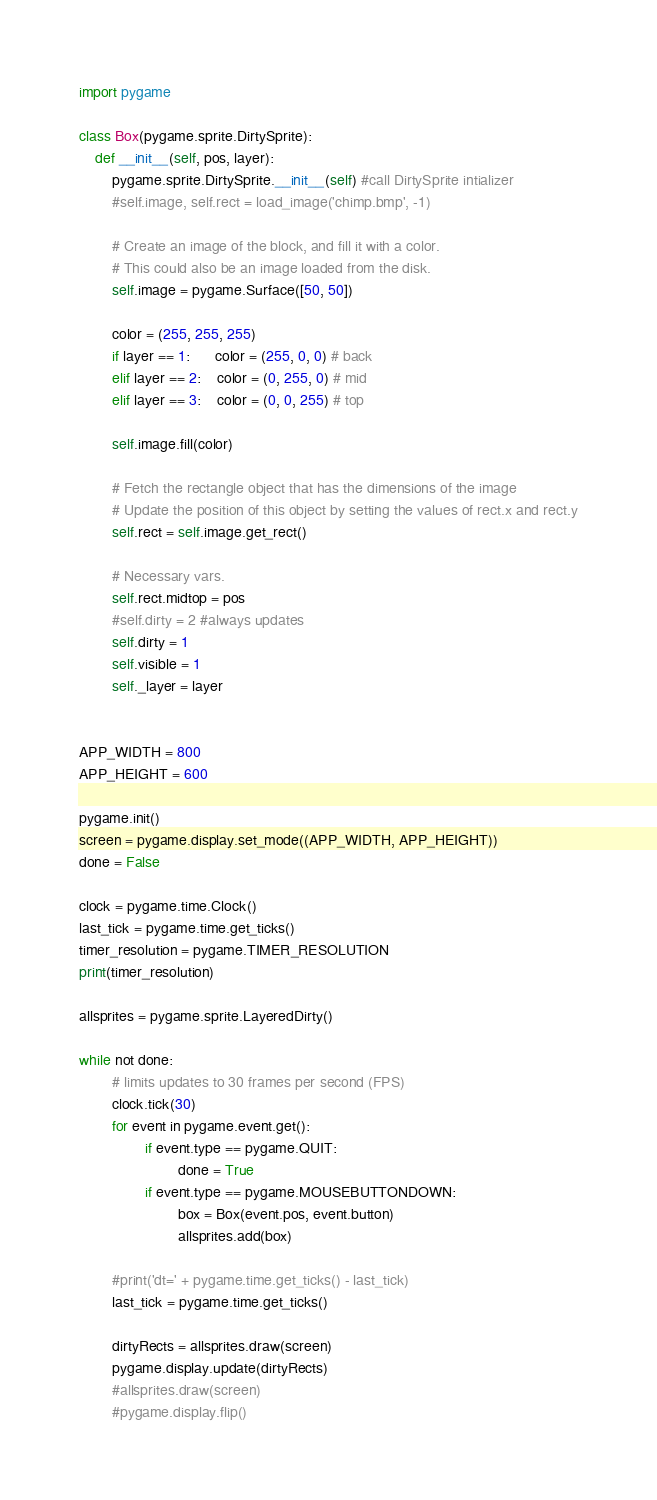Convert code to text. <code><loc_0><loc_0><loc_500><loc_500><_Python_>import pygame

class Box(pygame.sprite.DirtySprite):
    def __init__(self, pos, layer):
        pygame.sprite.DirtySprite.__init__(self) #call DirtySprite intializer
        #self.image, self.rect = load_image('chimp.bmp', -1)

        # Create an image of the block, and fill it with a color.
        # This could also be an image loaded from the disk.
        self.image = pygame.Surface([50, 50])

        color = (255, 255, 255)
        if layer == 1:      color = (255, 0, 0) # back
        elif layer == 2:    color = (0, 255, 0) # mid
        elif layer == 3:    color = (0, 0, 255) # top

        self.image.fill(color)

        # Fetch the rectangle object that has the dimensions of the image
        # Update the position of this object by setting the values of rect.x and rect.y
        self.rect = self.image.get_rect()

        # Necessary vars.
        self.rect.midtop = pos
        #self.dirty = 2 #always updates
        self.dirty = 1
        self.visible = 1
        self._layer = layer


APP_WIDTH = 800
APP_HEIGHT = 600

pygame.init()
screen = pygame.display.set_mode((APP_WIDTH, APP_HEIGHT))
done = False

clock = pygame.time.Clock()
last_tick = pygame.time.get_ticks()
timer_resolution = pygame.TIMER_RESOLUTION
print(timer_resolution)

allsprites = pygame.sprite.LayeredDirty()

while not done:
        # limits updates to 30 frames per second (FPS)
        clock.tick(30)
        for event in pygame.event.get():
                if event.type == pygame.QUIT:
                        done = True
                if event.type == pygame.MOUSEBUTTONDOWN:
                        box = Box(event.pos, event.button)
                        allsprites.add(box)

        #print('dt=' + pygame.time.get_ticks() - last_tick)
        last_tick = pygame.time.get_ticks()

        dirtyRects = allsprites.draw(screen)
        pygame.display.update(dirtyRects)
        #allsprites.draw(screen)
        #pygame.display.flip()
</code> 